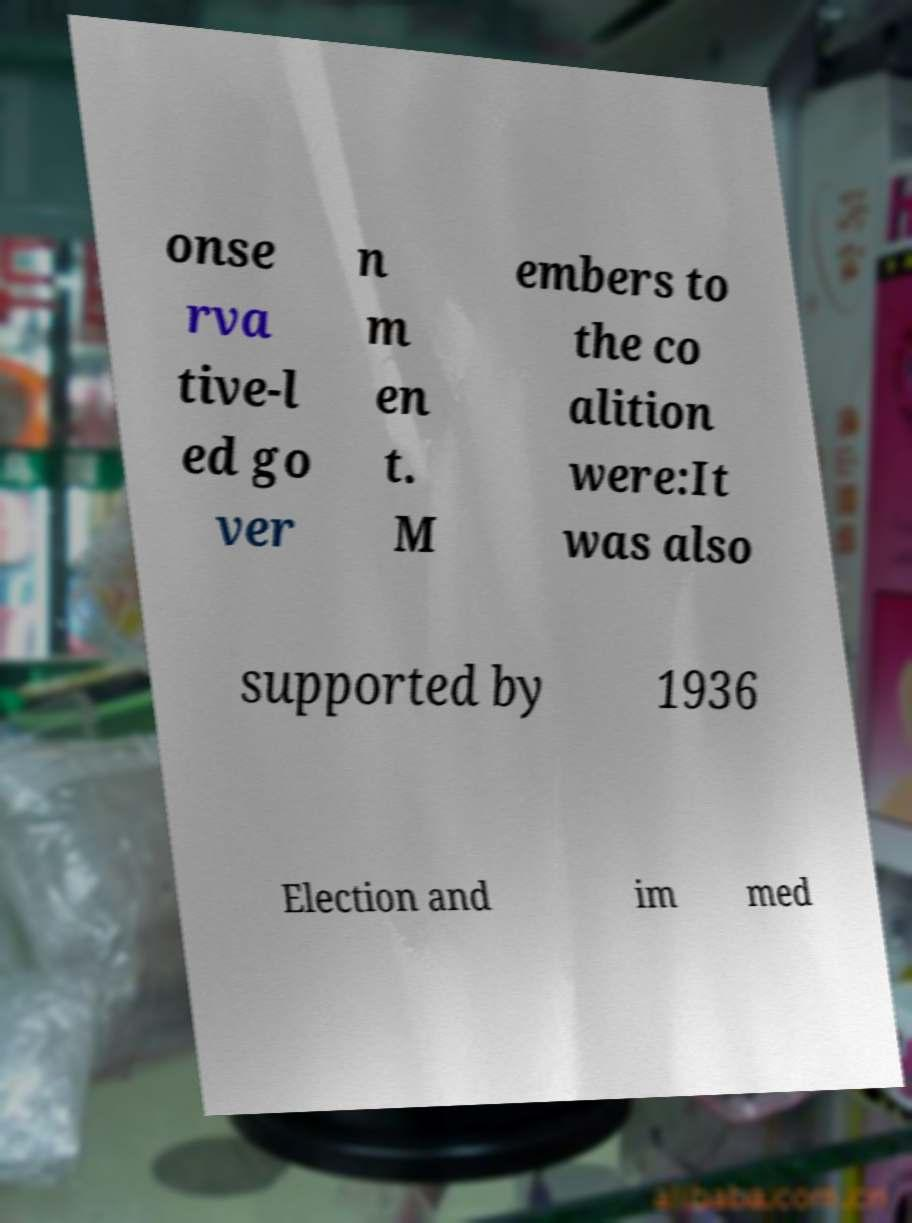I need the written content from this picture converted into text. Can you do that? onse rva tive-l ed go ver n m en t. M embers to the co alition were:It was also supported by 1936 Election and im med 